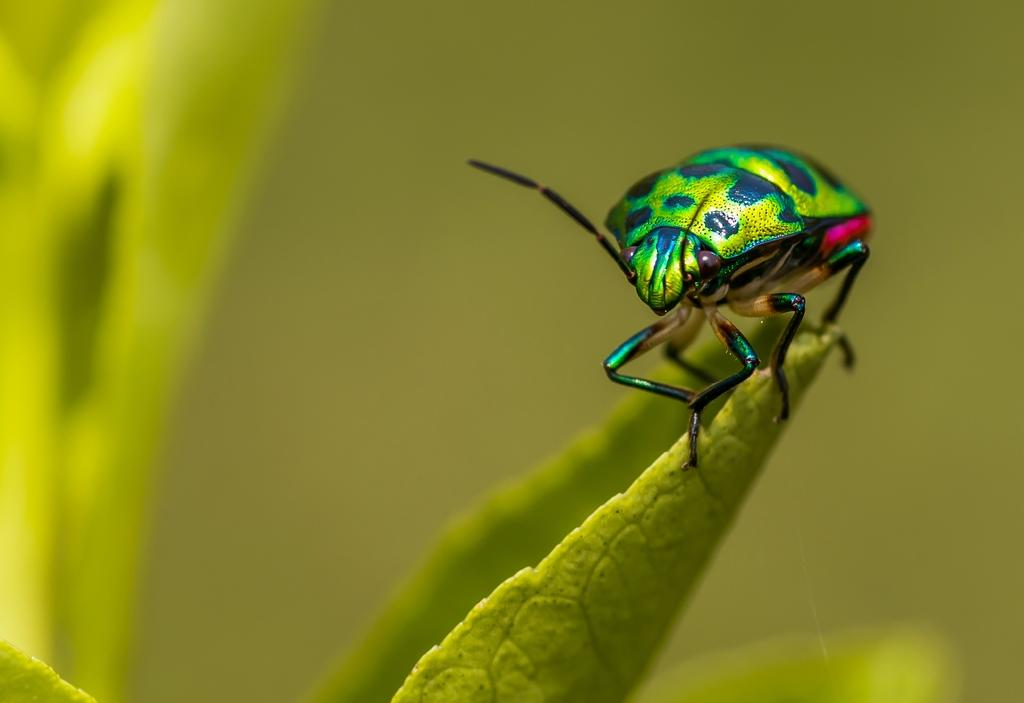What type of insect is in the image? There is a shield bug in the image. Where is the shield bug located? The shield bug is on a leaf. What shape is the afterthought in the image? There is no afterthought present in the image. Can you describe the slip in the image? There is no slip present in the image. 